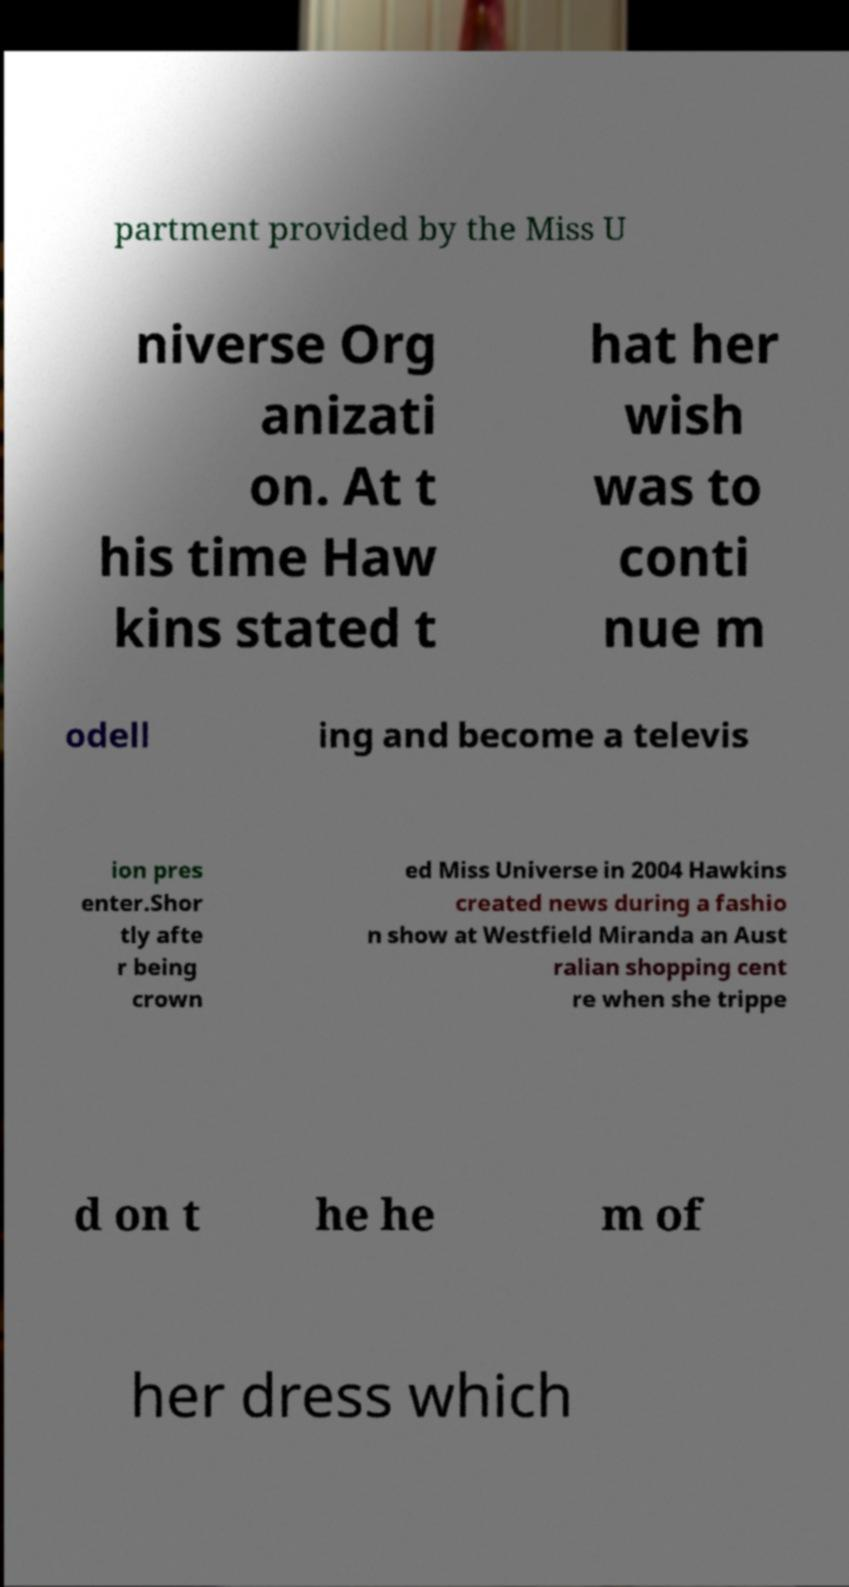Can you read and provide the text displayed in the image?This photo seems to have some interesting text. Can you extract and type it out for me? partment provided by the Miss U niverse Org anizati on. At t his time Haw kins stated t hat her wish was to conti nue m odell ing and become a televis ion pres enter.Shor tly afte r being crown ed Miss Universe in 2004 Hawkins created news during a fashio n show at Westfield Miranda an Aust ralian shopping cent re when she trippe d on t he he m of her dress which 